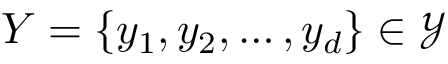Convert formula to latex. <formula><loc_0><loc_0><loc_500><loc_500>Y = \{ y _ { 1 } , y _ { 2 } , \dots , y _ { d } \} \in \mathcal { Y }</formula> 